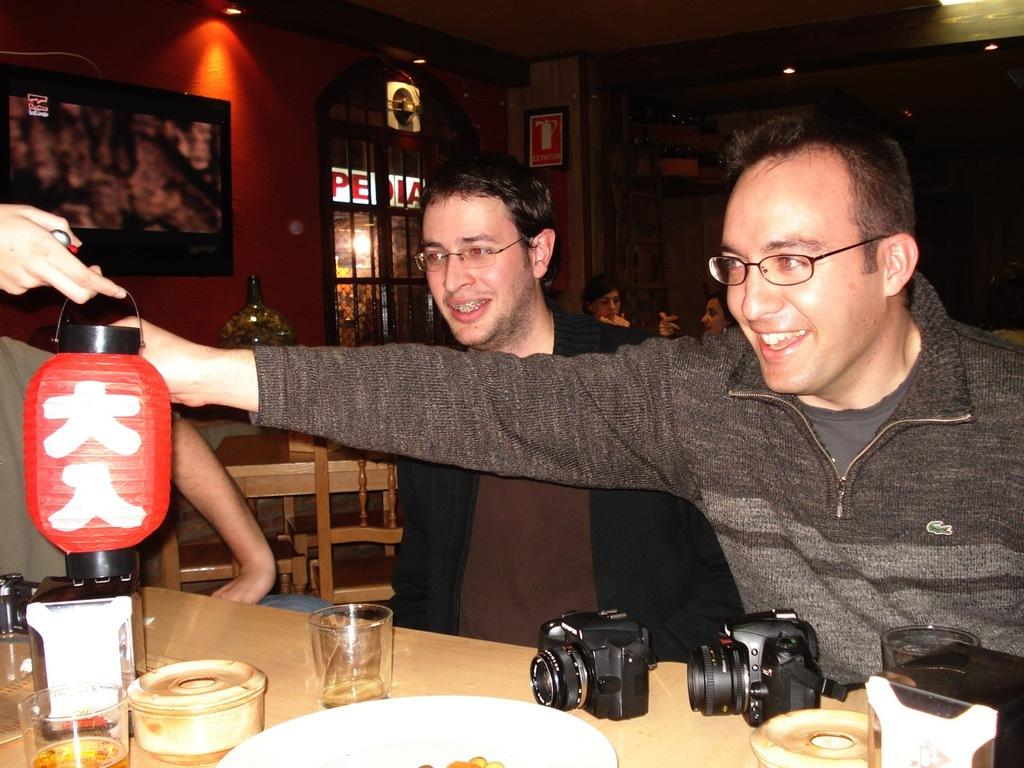How many people are in the image? There are two persons in the image. What is the facial expression of the persons in the image? The persons are smiling. What object can be seen in the image that might be used for holding or displaying items? There is a table in the image. What type of equipment is present on the table in the image? There are two cameras on the table. What type of peace is being promoted in the image? There is no reference to peace in the image. --- Facts: 1. There is a person in the image. 2. The person is holding a book. 3. The book is titled "The Art of War" by Sun Tzu. 4. The person is sitting on a chair. 5. The background of the image is a library. Absurd Topics: elephant, piano Conversation: How many people are in the image? There is one person in the image. What is the person holding in the image? The person is holding a book. What is the title of the book the person is holding in the image? The book is titled "The Art of War" by Sun Tzu. What is the person doing in the image? The person is sitting on a chair. What type of location is depicted in the background of the image? The background of the image is a library. Reasoning: Let's think step by step in order to produce the conversation. We start by identifying the main subject of the image, which is the person. Then, we describe what the person is holding, which is a book. Next, we mention the title of the book, which is "The Art of War" by Sun Tzu. After that, we observe the person's action, which is sitting on a chair. Finally, we describe the background location of the image, which is a library. Absurd Question/Answer: What type of elephant can be seen playing the piano in the image? There is no elephant or piano present in the image. 